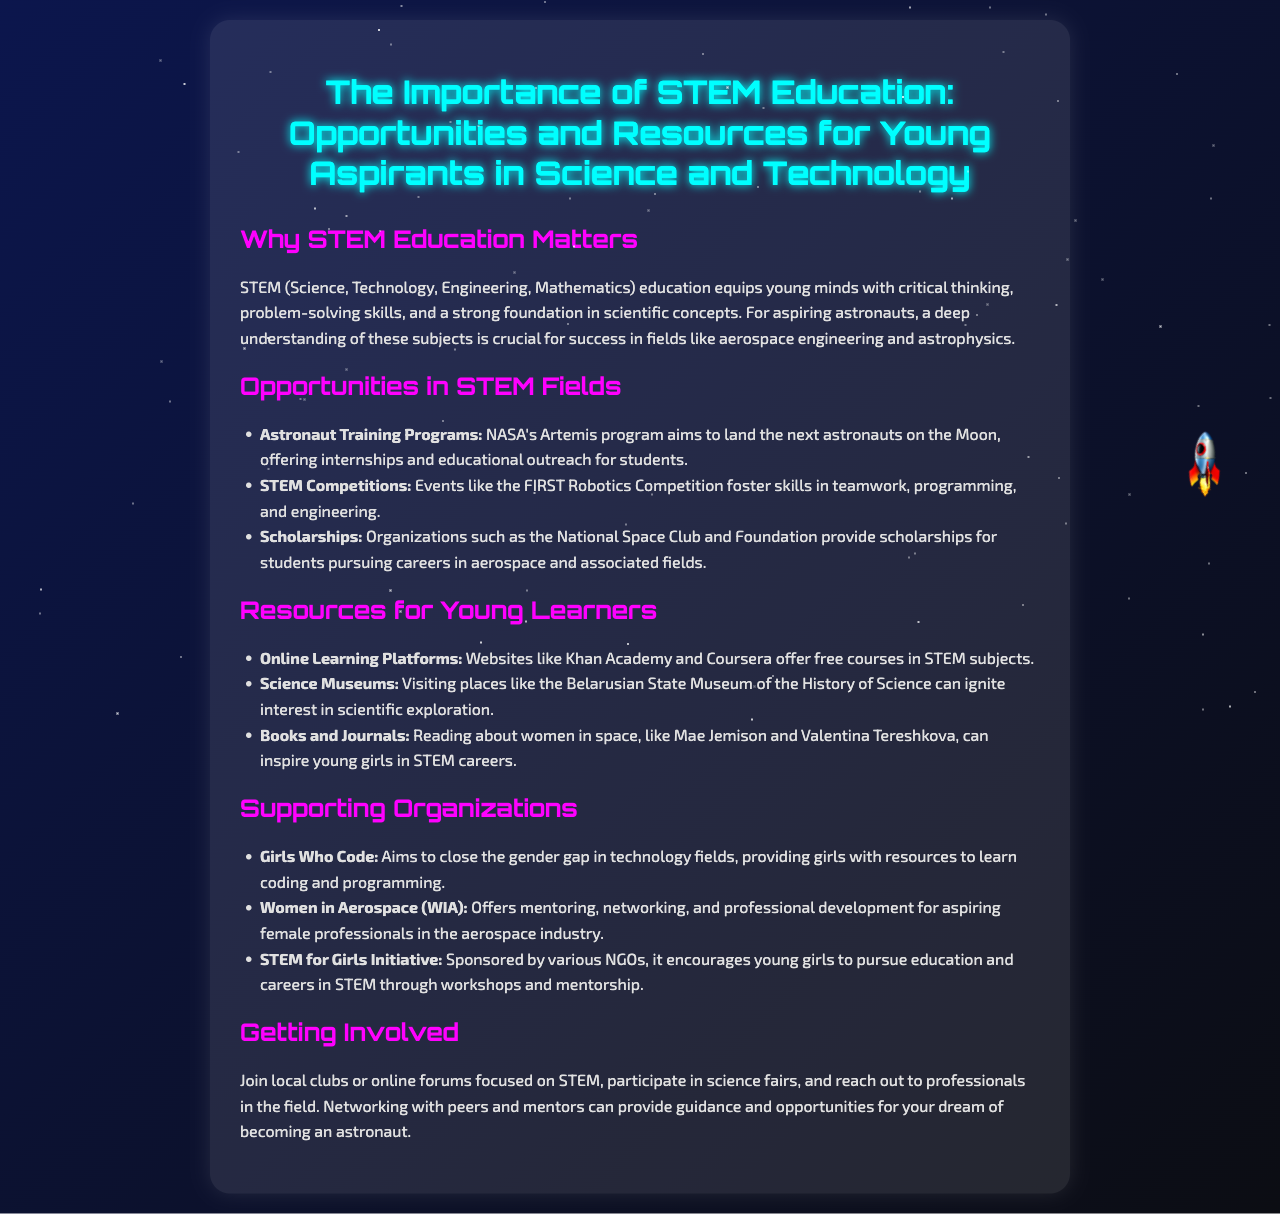What does STEM stand for? The document defines STEM as an acronym for Science, Technology, Engineering, Mathematics.
Answer: Science, Technology, Engineering, Mathematics What program aims to land the next astronauts on the Moon? The document mentions NASA's Artemis program as the initiative for Moon landings, which includes internships and educational outreach.
Answer: Artemis program What organization provides scholarships for students in aerospace fields? The document cites the National Space Club and Foundation as organizations that provide scholarships for aspiring aerospace students.
Answer: National Space Club and Foundation Name one online learning platform mentioned. The document lists Khan Academy and Coursera as platforms offering free courses in STEM subjects.
Answer: Khan Academy What initiative supports girls in coding? The document refers to Girls Who Code as an organization aimed at closing the gender gap in technology fields.
Answer: Girls Who Code How can young aspirants get involved in STEM? The document suggests joining local clubs or online forums, participating in science fairs, and networking with professionals as ways to get involved.
Answer: Join local clubs or online forums What resource can ignite interest in scientific exploration? The document notes that visiting science museums can ignite interest in science among young learners.
Answer: Science Museums What is one benefit of participating in STEM competitions? The document states that STEM competitions like the FIRST Robotics Competition foster skills in teamwork, programming, and engineering.
Answer: Teamwork, programming, engineering How does the Women in Aerospace organization support aspiring professionals? The document explains that Women in Aerospace offers mentoring, networking, and professional development for females in the aerospace industry.
Answer: Mentoring, networking, professional development 